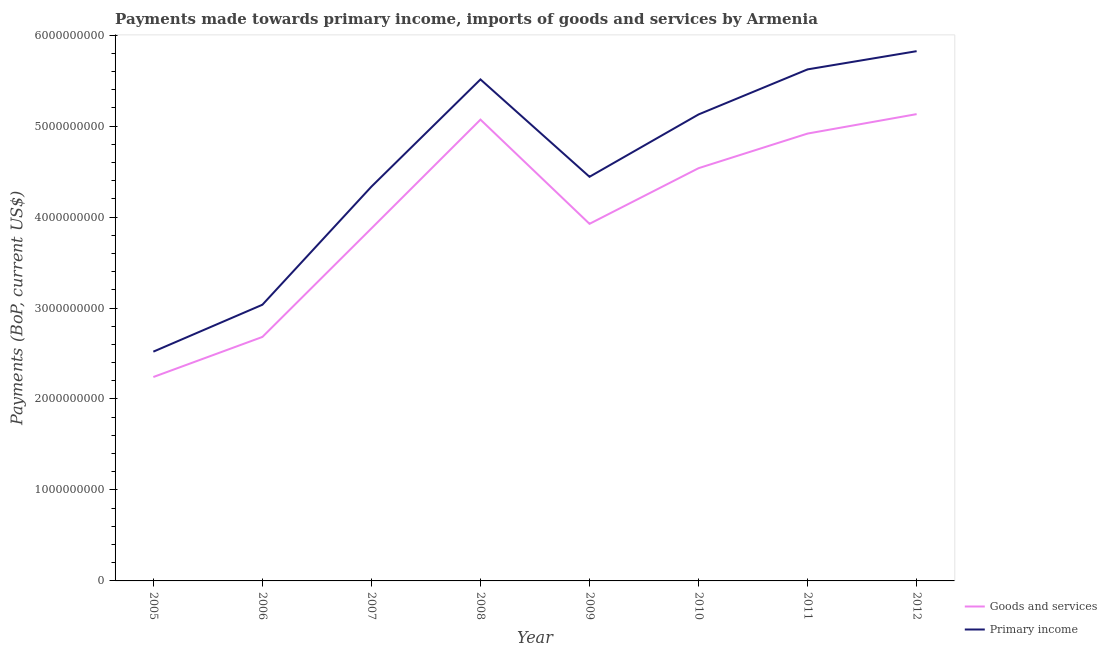How many different coloured lines are there?
Provide a succinct answer. 2. What is the payments made towards goods and services in 2011?
Ensure brevity in your answer.  4.92e+09. Across all years, what is the maximum payments made towards primary income?
Provide a short and direct response. 5.82e+09. Across all years, what is the minimum payments made towards goods and services?
Offer a terse response. 2.24e+09. In which year was the payments made towards goods and services maximum?
Your response must be concise. 2012. What is the total payments made towards goods and services in the graph?
Your answer should be very brief. 3.24e+1. What is the difference between the payments made towards goods and services in 2006 and that in 2012?
Provide a short and direct response. -2.45e+09. What is the difference between the payments made towards primary income in 2006 and the payments made towards goods and services in 2007?
Offer a terse response. -8.39e+08. What is the average payments made towards primary income per year?
Your answer should be very brief. 4.55e+09. In the year 2008, what is the difference between the payments made towards goods and services and payments made towards primary income?
Ensure brevity in your answer.  -4.42e+08. What is the ratio of the payments made towards goods and services in 2009 to that in 2011?
Provide a short and direct response. 0.8. Is the payments made towards primary income in 2008 less than that in 2011?
Your response must be concise. Yes. What is the difference between the highest and the second highest payments made towards goods and services?
Make the answer very short. 6.03e+07. What is the difference between the highest and the lowest payments made towards goods and services?
Give a very brief answer. 2.89e+09. Is the payments made towards goods and services strictly less than the payments made towards primary income over the years?
Offer a very short reply. Yes. Are the values on the major ticks of Y-axis written in scientific E-notation?
Provide a short and direct response. No. How many legend labels are there?
Provide a succinct answer. 2. What is the title of the graph?
Offer a very short reply. Payments made towards primary income, imports of goods and services by Armenia. Does "Frequency of shipment arrival" appear as one of the legend labels in the graph?
Offer a very short reply. No. What is the label or title of the Y-axis?
Make the answer very short. Payments (BoP, current US$). What is the Payments (BoP, current US$) of Goods and services in 2005?
Offer a very short reply. 2.24e+09. What is the Payments (BoP, current US$) of Primary income in 2005?
Your answer should be very brief. 2.52e+09. What is the Payments (BoP, current US$) of Goods and services in 2006?
Ensure brevity in your answer.  2.68e+09. What is the Payments (BoP, current US$) in Primary income in 2006?
Keep it short and to the point. 3.04e+09. What is the Payments (BoP, current US$) of Goods and services in 2007?
Make the answer very short. 3.88e+09. What is the Payments (BoP, current US$) of Primary income in 2007?
Offer a terse response. 4.33e+09. What is the Payments (BoP, current US$) in Goods and services in 2008?
Offer a terse response. 5.07e+09. What is the Payments (BoP, current US$) of Primary income in 2008?
Make the answer very short. 5.51e+09. What is the Payments (BoP, current US$) in Goods and services in 2009?
Make the answer very short. 3.93e+09. What is the Payments (BoP, current US$) in Primary income in 2009?
Offer a very short reply. 4.44e+09. What is the Payments (BoP, current US$) in Goods and services in 2010?
Your answer should be compact. 4.54e+09. What is the Payments (BoP, current US$) of Primary income in 2010?
Your answer should be very brief. 5.13e+09. What is the Payments (BoP, current US$) in Goods and services in 2011?
Your response must be concise. 4.92e+09. What is the Payments (BoP, current US$) of Primary income in 2011?
Offer a very short reply. 5.62e+09. What is the Payments (BoP, current US$) of Goods and services in 2012?
Your response must be concise. 5.13e+09. What is the Payments (BoP, current US$) of Primary income in 2012?
Your response must be concise. 5.82e+09. Across all years, what is the maximum Payments (BoP, current US$) of Goods and services?
Offer a terse response. 5.13e+09. Across all years, what is the maximum Payments (BoP, current US$) in Primary income?
Offer a very short reply. 5.82e+09. Across all years, what is the minimum Payments (BoP, current US$) of Goods and services?
Offer a terse response. 2.24e+09. Across all years, what is the minimum Payments (BoP, current US$) of Primary income?
Provide a short and direct response. 2.52e+09. What is the total Payments (BoP, current US$) in Goods and services in the graph?
Ensure brevity in your answer.  3.24e+1. What is the total Payments (BoP, current US$) of Primary income in the graph?
Your response must be concise. 3.64e+1. What is the difference between the Payments (BoP, current US$) of Goods and services in 2005 and that in 2006?
Offer a very short reply. -4.41e+08. What is the difference between the Payments (BoP, current US$) in Primary income in 2005 and that in 2006?
Give a very brief answer. -5.16e+08. What is the difference between the Payments (BoP, current US$) in Goods and services in 2005 and that in 2007?
Keep it short and to the point. -1.63e+09. What is the difference between the Payments (BoP, current US$) of Primary income in 2005 and that in 2007?
Make the answer very short. -1.81e+09. What is the difference between the Payments (BoP, current US$) in Goods and services in 2005 and that in 2008?
Offer a terse response. -2.83e+09. What is the difference between the Payments (BoP, current US$) in Primary income in 2005 and that in 2008?
Offer a terse response. -2.99e+09. What is the difference between the Payments (BoP, current US$) of Goods and services in 2005 and that in 2009?
Your answer should be very brief. -1.68e+09. What is the difference between the Payments (BoP, current US$) in Primary income in 2005 and that in 2009?
Offer a very short reply. -1.92e+09. What is the difference between the Payments (BoP, current US$) in Goods and services in 2005 and that in 2010?
Offer a very short reply. -2.30e+09. What is the difference between the Payments (BoP, current US$) in Primary income in 2005 and that in 2010?
Give a very brief answer. -2.61e+09. What is the difference between the Payments (BoP, current US$) of Goods and services in 2005 and that in 2011?
Your response must be concise. -2.68e+09. What is the difference between the Payments (BoP, current US$) of Primary income in 2005 and that in 2011?
Your response must be concise. -3.10e+09. What is the difference between the Payments (BoP, current US$) of Goods and services in 2005 and that in 2012?
Provide a succinct answer. -2.89e+09. What is the difference between the Payments (BoP, current US$) of Primary income in 2005 and that in 2012?
Give a very brief answer. -3.30e+09. What is the difference between the Payments (BoP, current US$) in Goods and services in 2006 and that in 2007?
Your response must be concise. -1.19e+09. What is the difference between the Payments (BoP, current US$) in Primary income in 2006 and that in 2007?
Give a very brief answer. -1.30e+09. What is the difference between the Payments (BoP, current US$) in Goods and services in 2006 and that in 2008?
Your response must be concise. -2.39e+09. What is the difference between the Payments (BoP, current US$) in Primary income in 2006 and that in 2008?
Your answer should be very brief. -2.48e+09. What is the difference between the Payments (BoP, current US$) in Goods and services in 2006 and that in 2009?
Give a very brief answer. -1.24e+09. What is the difference between the Payments (BoP, current US$) of Primary income in 2006 and that in 2009?
Your answer should be very brief. -1.41e+09. What is the difference between the Payments (BoP, current US$) in Goods and services in 2006 and that in 2010?
Ensure brevity in your answer.  -1.86e+09. What is the difference between the Payments (BoP, current US$) in Primary income in 2006 and that in 2010?
Offer a very short reply. -2.09e+09. What is the difference between the Payments (BoP, current US$) in Goods and services in 2006 and that in 2011?
Make the answer very short. -2.24e+09. What is the difference between the Payments (BoP, current US$) of Primary income in 2006 and that in 2011?
Offer a terse response. -2.59e+09. What is the difference between the Payments (BoP, current US$) of Goods and services in 2006 and that in 2012?
Provide a succinct answer. -2.45e+09. What is the difference between the Payments (BoP, current US$) of Primary income in 2006 and that in 2012?
Give a very brief answer. -2.79e+09. What is the difference between the Payments (BoP, current US$) in Goods and services in 2007 and that in 2008?
Your answer should be very brief. -1.20e+09. What is the difference between the Payments (BoP, current US$) of Primary income in 2007 and that in 2008?
Ensure brevity in your answer.  -1.18e+09. What is the difference between the Payments (BoP, current US$) of Goods and services in 2007 and that in 2009?
Your answer should be compact. -5.03e+07. What is the difference between the Payments (BoP, current US$) in Primary income in 2007 and that in 2009?
Keep it short and to the point. -1.08e+08. What is the difference between the Payments (BoP, current US$) in Goods and services in 2007 and that in 2010?
Give a very brief answer. -6.62e+08. What is the difference between the Payments (BoP, current US$) of Primary income in 2007 and that in 2010?
Your response must be concise. -7.94e+08. What is the difference between the Payments (BoP, current US$) of Goods and services in 2007 and that in 2011?
Your response must be concise. -1.04e+09. What is the difference between the Payments (BoP, current US$) in Primary income in 2007 and that in 2011?
Give a very brief answer. -1.29e+09. What is the difference between the Payments (BoP, current US$) in Goods and services in 2007 and that in 2012?
Your response must be concise. -1.26e+09. What is the difference between the Payments (BoP, current US$) in Primary income in 2007 and that in 2012?
Keep it short and to the point. -1.49e+09. What is the difference between the Payments (BoP, current US$) in Goods and services in 2008 and that in 2009?
Your answer should be very brief. 1.15e+09. What is the difference between the Payments (BoP, current US$) of Primary income in 2008 and that in 2009?
Your answer should be compact. 1.07e+09. What is the difference between the Payments (BoP, current US$) of Goods and services in 2008 and that in 2010?
Your response must be concise. 5.34e+08. What is the difference between the Payments (BoP, current US$) of Primary income in 2008 and that in 2010?
Offer a very short reply. 3.85e+08. What is the difference between the Payments (BoP, current US$) in Goods and services in 2008 and that in 2011?
Provide a short and direct response. 1.53e+08. What is the difference between the Payments (BoP, current US$) of Primary income in 2008 and that in 2011?
Your answer should be very brief. -1.10e+08. What is the difference between the Payments (BoP, current US$) in Goods and services in 2008 and that in 2012?
Provide a short and direct response. -6.03e+07. What is the difference between the Payments (BoP, current US$) in Primary income in 2008 and that in 2012?
Offer a very short reply. -3.10e+08. What is the difference between the Payments (BoP, current US$) of Goods and services in 2009 and that in 2010?
Give a very brief answer. -6.12e+08. What is the difference between the Payments (BoP, current US$) of Primary income in 2009 and that in 2010?
Provide a short and direct response. -6.85e+08. What is the difference between the Payments (BoP, current US$) in Goods and services in 2009 and that in 2011?
Your answer should be very brief. -9.92e+08. What is the difference between the Payments (BoP, current US$) in Primary income in 2009 and that in 2011?
Your response must be concise. -1.18e+09. What is the difference between the Payments (BoP, current US$) of Goods and services in 2009 and that in 2012?
Give a very brief answer. -1.21e+09. What is the difference between the Payments (BoP, current US$) in Primary income in 2009 and that in 2012?
Offer a terse response. -1.38e+09. What is the difference between the Payments (BoP, current US$) of Goods and services in 2010 and that in 2011?
Your response must be concise. -3.81e+08. What is the difference between the Payments (BoP, current US$) of Primary income in 2010 and that in 2011?
Your answer should be compact. -4.95e+08. What is the difference between the Payments (BoP, current US$) of Goods and services in 2010 and that in 2012?
Offer a very short reply. -5.94e+08. What is the difference between the Payments (BoP, current US$) of Primary income in 2010 and that in 2012?
Provide a succinct answer. -6.96e+08. What is the difference between the Payments (BoP, current US$) of Goods and services in 2011 and that in 2012?
Your answer should be compact. -2.14e+08. What is the difference between the Payments (BoP, current US$) of Primary income in 2011 and that in 2012?
Keep it short and to the point. -2.00e+08. What is the difference between the Payments (BoP, current US$) in Goods and services in 2005 and the Payments (BoP, current US$) in Primary income in 2006?
Provide a succinct answer. -7.94e+08. What is the difference between the Payments (BoP, current US$) in Goods and services in 2005 and the Payments (BoP, current US$) in Primary income in 2007?
Make the answer very short. -2.09e+09. What is the difference between the Payments (BoP, current US$) of Goods and services in 2005 and the Payments (BoP, current US$) of Primary income in 2008?
Make the answer very short. -3.27e+09. What is the difference between the Payments (BoP, current US$) in Goods and services in 2005 and the Payments (BoP, current US$) in Primary income in 2009?
Offer a terse response. -2.20e+09. What is the difference between the Payments (BoP, current US$) of Goods and services in 2005 and the Payments (BoP, current US$) of Primary income in 2010?
Provide a short and direct response. -2.89e+09. What is the difference between the Payments (BoP, current US$) of Goods and services in 2005 and the Payments (BoP, current US$) of Primary income in 2011?
Make the answer very short. -3.38e+09. What is the difference between the Payments (BoP, current US$) of Goods and services in 2005 and the Payments (BoP, current US$) of Primary income in 2012?
Ensure brevity in your answer.  -3.58e+09. What is the difference between the Payments (BoP, current US$) in Goods and services in 2006 and the Payments (BoP, current US$) in Primary income in 2007?
Provide a succinct answer. -1.65e+09. What is the difference between the Payments (BoP, current US$) of Goods and services in 2006 and the Payments (BoP, current US$) of Primary income in 2008?
Make the answer very short. -2.83e+09. What is the difference between the Payments (BoP, current US$) of Goods and services in 2006 and the Payments (BoP, current US$) of Primary income in 2009?
Make the answer very short. -1.76e+09. What is the difference between the Payments (BoP, current US$) in Goods and services in 2006 and the Payments (BoP, current US$) in Primary income in 2010?
Make the answer very short. -2.45e+09. What is the difference between the Payments (BoP, current US$) of Goods and services in 2006 and the Payments (BoP, current US$) of Primary income in 2011?
Offer a very short reply. -2.94e+09. What is the difference between the Payments (BoP, current US$) of Goods and services in 2006 and the Payments (BoP, current US$) of Primary income in 2012?
Make the answer very short. -3.14e+09. What is the difference between the Payments (BoP, current US$) of Goods and services in 2007 and the Payments (BoP, current US$) of Primary income in 2008?
Offer a very short reply. -1.64e+09. What is the difference between the Payments (BoP, current US$) in Goods and services in 2007 and the Payments (BoP, current US$) in Primary income in 2009?
Provide a short and direct response. -5.67e+08. What is the difference between the Payments (BoP, current US$) of Goods and services in 2007 and the Payments (BoP, current US$) of Primary income in 2010?
Offer a terse response. -1.25e+09. What is the difference between the Payments (BoP, current US$) in Goods and services in 2007 and the Payments (BoP, current US$) in Primary income in 2011?
Provide a short and direct response. -1.75e+09. What is the difference between the Payments (BoP, current US$) of Goods and services in 2007 and the Payments (BoP, current US$) of Primary income in 2012?
Provide a succinct answer. -1.95e+09. What is the difference between the Payments (BoP, current US$) of Goods and services in 2008 and the Payments (BoP, current US$) of Primary income in 2009?
Provide a short and direct response. 6.29e+08. What is the difference between the Payments (BoP, current US$) in Goods and services in 2008 and the Payments (BoP, current US$) in Primary income in 2010?
Offer a very short reply. -5.69e+07. What is the difference between the Payments (BoP, current US$) of Goods and services in 2008 and the Payments (BoP, current US$) of Primary income in 2011?
Give a very brief answer. -5.52e+08. What is the difference between the Payments (BoP, current US$) in Goods and services in 2008 and the Payments (BoP, current US$) in Primary income in 2012?
Offer a terse response. -7.52e+08. What is the difference between the Payments (BoP, current US$) in Goods and services in 2009 and the Payments (BoP, current US$) in Primary income in 2010?
Provide a short and direct response. -1.20e+09. What is the difference between the Payments (BoP, current US$) in Goods and services in 2009 and the Payments (BoP, current US$) in Primary income in 2011?
Give a very brief answer. -1.70e+09. What is the difference between the Payments (BoP, current US$) of Goods and services in 2009 and the Payments (BoP, current US$) of Primary income in 2012?
Offer a very short reply. -1.90e+09. What is the difference between the Payments (BoP, current US$) of Goods and services in 2010 and the Payments (BoP, current US$) of Primary income in 2011?
Offer a very short reply. -1.09e+09. What is the difference between the Payments (BoP, current US$) of Goods and services in 2010 and the Payments (BoP, current US$) of Primary income in 2012?
Make the answer very short. -1.29e+09. What is the difference between the Payments (BoP, current US$) in Goods and services in 2011 and the Payments (BoP, current US$) in Primary income in 2012?
Your answer should be very brief. -9.06e+08. What is the average Payments (BoP, current US$) of Goods and services per year?
Ensure brevity in your answer.  4.05e+09. What is the average Payments (BoP, current US$) of Primary income per year?
Ensure brevity in your answer.  4.55e+09. In the year 2005, what is the difference between the Payments (BoP, current US$) of Goods and services and Payments (BoP, current US$) of Primary income?
Offer a very short reply. -2.79e+08. In the year 2006, what is the difference between the Payments (BoP, current US$) in Goods and services and Payments (BoP, current US$) in Primary income?
Your answer should be very brief. -3.54e+08. In the year 2007, what is the difference between the Payments (BoP, current US$) of Goods and services and Payments (BoP, current US$) of Primary income?
Provide a succinct answer. -4.59e+08. In the year 2008, what is the difference between the Payments (BoP, current US$) in Goods and services and Payments (BoP, current US$) in Primary income?
Your answer should be compact. -4.42e+08. In the year 2009, what is the difference between the Payments (BoP, current US$) in Goods and services and Payments (BoP, current US$) in Primary income?
Your answer should be compact. -5.17e+08. In the year 2010, what is the difference between the Payments (BoP, current US$) of Goods and services and Payments (BoP, current US$) of Primary income?
Your answer should be compact. -5.91e+08. In the year 2011, what is the difference between the Payments (BoP, current US$) of Goods and services and Payments (BoP, current US$) of Primary income?
Your answer should be very brief. -7.05e+08. In the year 2012, what is the difference between the Payments (BoP, current US$) in Goods and services and Payments (BoP, current US$) in Primary income?
Keep it short and to the point. -6.92e+08. What is the ratio of the Payments (BoP, current US$) of Goods and services in 2005 to that in 2006?
Offer a very short reply. 0.84. What is the ratio of the Payments (BoP, current US$) in Primary income in 2005 to that in 2006?
Keep it short and to the point. 0.83. What is the ratio of the Payments (BoP, current US$) of Goods and services in 2005 to that in 2007?
Keep it short and to the point. 0.58. What is the ratio of the Payments (BoP, current US$) in Primary income in 2005 to that in 2007?
Make the answer very short. 0.58. What is the ratio of the Payments (BoP, current US$) of Goods and services in 2005 to that in 2008?
Ensure brevity in your answer.  0.44. What is the ratio of the Payments (BoP, current US$) in Primary income in 2005 to that in 2008?
Offer a very short reply. 0.46. What is the ratio of the Payments (BoP, current US$) of Goods and services in 2005 to that in 2009?
Provide a short and direct response. 0.57. What is the ratio of the Payments (BoP, current US$) of Primary income in 2005 to that in 2009?
Give a very brief answer. 0.57. What is the ratio of the Payments (BoP, current US$) in Goods and services in 2005 to that in 2010?
Offer a terse response. 0.49. What is the ratio of the Payments (BoP, current US$) in Primary income in 2005 to that in 2010?
Ensure brevity in your answer.  0.49. What is the ratio of the Payments (BoP, current US$) of Goods and services in 2005 to that in 2011?
Make the answer very short. 0.46. What is the ratio of the Payments (BoP, current US$) of Primary income in 2005 to that in 2011?
Provide a short and direct response. 0.45. What is the ratio of the Payments (BoP, current US$) of Goods and services in 2005 to that in 2012?
Provide a short and direct response. 0.44. What is the ratio of the Payments (BoP, current US$) of Primary income in 2005 to that in 2012?
Ensure brevity in your answer.  0.43. What is the ratio of the Payments (BoP, current US$) of Goods and services in 2006 to that in 2007?
Provide a succinct answer. 0.69. What is the ratio of the Payments (BoP, current US$) of Primary income in 2006 to that in 2007?
Your response must be concise. 0.7. What is the ratio of the Payments (BoP, current US$) of Goods and services in 2006 to that in 2008?
Give a very brief answer. 0.53. What is the ratio of the Payments (BoP, current US$) in Primary income in 2006 to that in 2008?
Provide a short and direct response. 0.55. What is the ratio of the Payments (BoP, current US$) of Goods and services in 2006 to that in 2009?
Provide a short and direct response. 0.68. What is the ratio of the Payments (BoP, current US$) of Primary income in 2006 to that in 2009?
Ensure brevity in your answer.  0.68. What is the ratio of the Payments (BoP, current US$) in Goods and services in 2006 to that in 2010?
Give a very brief answer. 0.59. What is the ratio of the Payments (BoP, current US$) of Primary income in 2006 to that in 2010?
Your answer should be compact. 0.59. What is the ratio of the Payments (BoP, current US$) in Goods and services in 2006 to that in 2011?
Give a very brief answer. 0.55. What is the ratio of the Payments (BoP, current US$) in Primary income in 2006 to that in 2011?
Provide a short and direct response. 0.54. What is the ratio of the Payments (BoP, current US$) of Goods and services in 2006 to that in 2012?
Provide a succinct answer. 0.52. What is the ratio of the Payments (BoP, current US$) of Primary income in 2006 to that in 2012?
Your answer should be compact. 0.52. What is the ratio of the Payments (BoP, current US$) of Goods and services in 2007 to that in 2008?
Provide a succinct answer. 0.76. What is the ratio of the Payments (BoP, current US$) of Primary income in 2007 to that in 2008?
Your answer should be very brief. 0.79. What is the ratio of the Payments (BoP, current US$) of Goods and services in 2007 to that in 2009?
Your answer should be very brief. 0.99. What is the ratio of the Payments (BoP, current US$) in Primary income in 2007 to that in 2009?
Provide a succinct answer. 0.98. What is the ratio of the Payments (BoP, current US$) in Goods and services in 2007 to that in 2010?
Offer a terse response. 0.85. What is the ratio of the Payments (BoP, current US$) of Primary income in 2007 to that in 2010?
Provide a succinct answer. 0.85. What is the ratio of the Payments (BoP, current US$) in Goods and services in 2007 to that in 2011?
Your response must be concise. 0.79. What is the ratio of the Payments (BoP, current US$) of Primary income in 2007 to that in 2011?
Keep it short and to the point. 0.77. What is the ratio of the Payments (BoP, current US$) in Goods and services in 2007 to that in 2012?
Provide a succinct answer. 0.76. What is the ratio of the Payments (BoP, current US$) of Primary income in 2007 to that in 2012?
Provide a succinct answer. 0.74. What is the ratio of the Payments (BoP, current US$) of Goods and services in 2008 to that in 2009?
Your answer should be very brief. 1.29. What is the ratio of the Payments (BoP, current US$) of Primary income in 2008 to that in 2009?
Provide a succinct answer. 1.24. What is the ratio of the Payments (BoP, current US$) of Goods and services in 2008 to that in 2010?
Provide a succinct answer. 1.12. What is the ratio of the Payments (BoP, current US$) of Primary income in 2008 to that in 2010?
Your answer should be very brief. 1.08. What is the ratio of the Payments (BoP, current US$) in Goods and services in 2008 to that in 2011?
Offer a very short reply. 1.03. What is the ratio of the Payments (BoP, current US$) of Primary income in 2008 to that in 2011?
Keep it short and to the point. 0.98. What is the ratio of the Payments (BoP, current US$) in Goods and services in 2008 to that in 2012?
Give a very brief answer. 0.99. What is the ratio of the Payments (BoP, current US$) of Primary income in 2008 to that in 2012?
Keep it short and to the point. 0.95. What is the ratio of the Payments (BoP, current US$) of Goods and services in 2009 to that in 2010?
Keep it short and to the point. 0.87. What is the ratio of the Payments (BoP, current US$) of Primary income in 2009 to that in 2010?
Provide a succinct answer. 0.87. What is the ratio of the Payments (BoP, current US$) of Goods and services in 2009 to that in 2011?
Offer a terse response. 0.8. What is the ratio of the Payments (BoP, current US$) in Primary income in 2009 to that in 2011?
Ensure brevity in your answer.  0.79. What is the ratio of the Payments (BoP, current US$) in Goods and services in 2009 to that in 2012?
Your answer should be very brief. 0.77. What is the ratio of the Payments (BoP, current US$) in Primary income in 2009 to that in 2012?
Offer a very short reply. 0.76. What is the ratio of the Payments (BoP, current US$) in Goods and services in 2010 to that in 2011?
Your response must be concise. 0.92. What is the ratio of the Payments (BoP, current US$) of Primary income in 2010 to that in 2011?
Offer a terse response. 0.91. What is the ratio of the Payments (BoP, current US$) in Goods and services in 2010 to that in 2012?
Keep it short and to the point. 0.88. What is the ratio of the Payments (BoP, current US$) in Primary income in 2010 to that in 2012?
Your answer should be very brief. 0.88. What is the ratio of the Payments (BoP, current US$) of Goods and services in 2011 to that in 2012?
Give a very brief answer. 0.96. What is the ratio of the Payments (BoP, current US$) in Primary income in 2011 to that in 2012?
Offer a very short reply. 0.97. What is the difference between the highest and the second highest Payments (BoP, current US$) of Goods and services?
Offer a very short reply. 6.03e+07. What is the difference between the highest and the second highest Payments (BoP, current US$) of Primary income?
Offer a terse response. 2.00e+08. What is the difference between the highest and the lowest Payments (BoP, current US$) of Goods and services?
Provide a short and direct response. 2.89e+09. What is the difference between the highest and the lowest Payments (BoP, current US$) of Primary income?
Provide a succinct answer. 3.30e+09. 